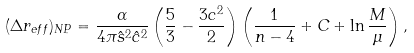Convert formula to latex. <formula><loc_0><loc_0><loc_500><loc_500>( \Delta r _ { e f f } ) _ { N P } = \frac { \alpha } { 4 \pi \hat { s } ^ { 2 } \hat { c } ^ { 2 } } \left ( \frac { 5 } { 3 } - \frac { 3 c ^ { 2 } } { 2 } \right ) \left ( \frac { 1 } { n - 4 } + C + \ln \frac { M } { \mu } \right ) ,</formula> 